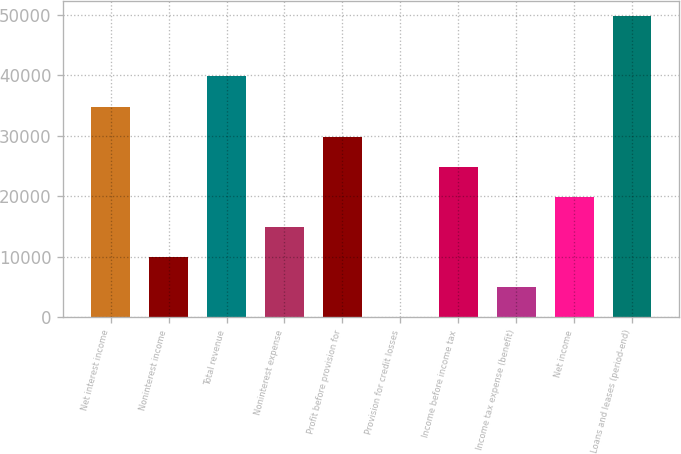Convert chart to OTSL. <chart><loc_0><loc_0><loc_500><loc_500><bar_chart><fcel>Net interest income<fcel>Noninterest income<fcel>Total revenue<fcel>Noninterest expense<fcel>Profit before provision for<fcel>Provision for credit losses<fcel>Income before income tax<fcel>Income tax expense (benefit)<fcel>Net income<fcel>Loans and leases (period-end)<nl><fcel>34828.6<fcel>9964.6<fcel>39801.4<fcel>14937.4<fcel>29855.8<fcel>19<fcel>24883<fcel>4991.8<fcel>19910.2<fcel>49747<nl></chart> 